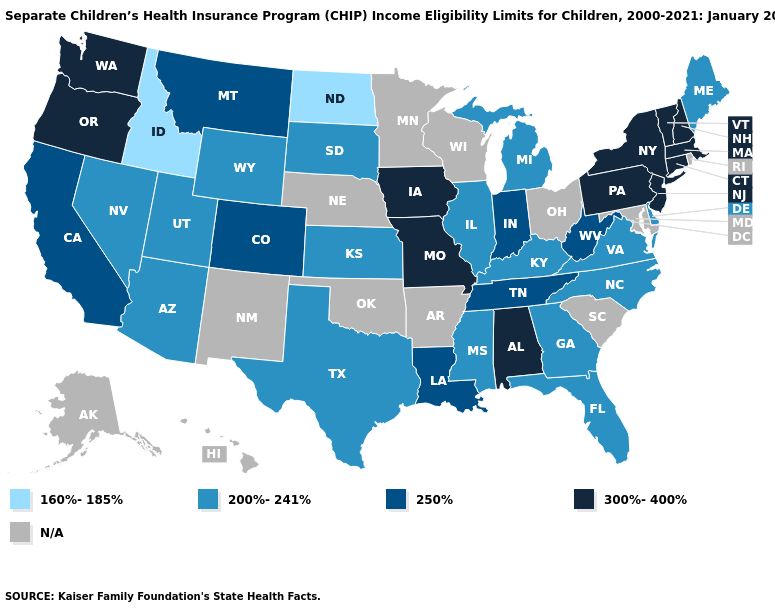Among the states that border Kentucky , which have the highest value?
Short answer required. Missouri. Which states have the highest value in the USA?
Be succinct. Alabama, Connecticut, Iowa, Massachusetts, Missouri, New Hampshire, New Jersey, New York, Oregon, Pennsylvania, Vermont, Washington. What is the value of Florida?
Be succinct. 200%-241%. Name the states that have a value in the range 160%-185%?
Keep it brief. Idaho, North Dakota. Name the states that have a value in the range N/A?
Answer briefly. Alaska, Arkansas, Hawaii, Maryland, Minnesota, Nebraska, New Mexico, Ohio, Oklahoma, Rhode Island, South Carolina, Wisconsin. Does Idaho have the lowest value in the USA?
Keep it brief. Yes. What is the lowest value in the Northeast?
Concise answer only. 200%-241%. Does California have the highest value in the West?
Quick response, please. No. What is the value of Ohio?
Short answer required. N/A. Does New Hampshire have the lowest value in the USA?
Answer briefly. No. Does Louisiana have the lowest value in the USA?
Concise answer only. No. Which states have the lowest value in the South?
Short answer required. Delaware, Florida, Georgia, Kentucky, Mississippi, North Carolina, Texas, Virginia. Among the states that border Georgia , does Tennessee have the highest value?
Concise answer only. No. Which states have the lowest value in the Northeast?
Answer briefly. Maine. Name the states that have a value in the range 200%-241%?
Concise answer only. Arizona, Delaware, Florida, Georgia, Illinois, Kansas, Kentucky, Maine, Michigan, Mississippi, Nevada, North Carolina, South Dakota, Texas, Utah, Virginia, Wyoming. 